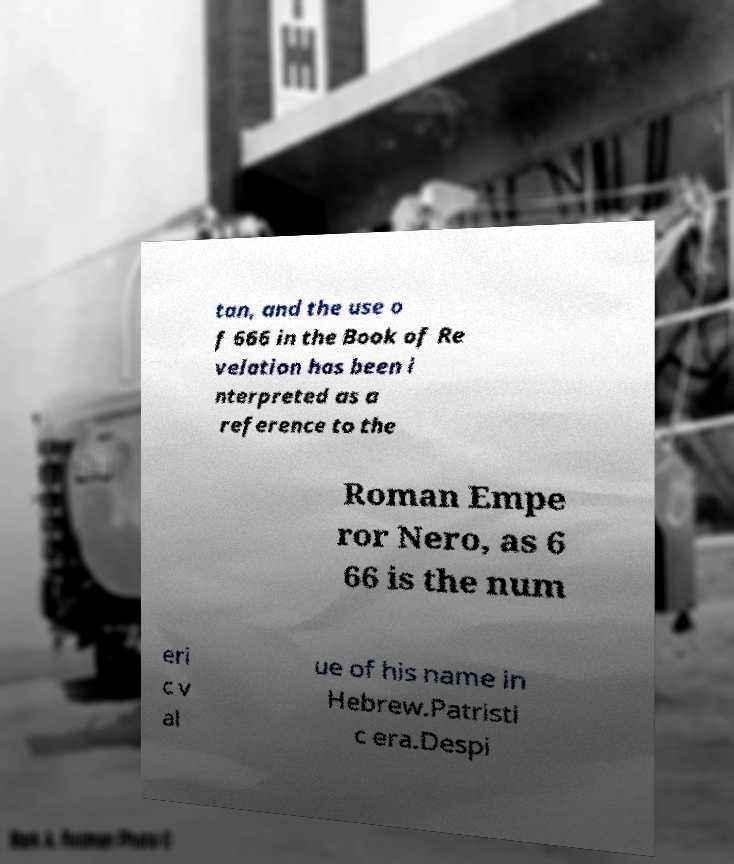Please identify and transcribe the text found in this image. tan, and the use o f 666 in the Book of Re velation has been i nterpreted as a reference to the Roman Empe ror Nero, as 6 66 is the num eri c v al ue of his name in Hebrew.Patristi c era.Despi 